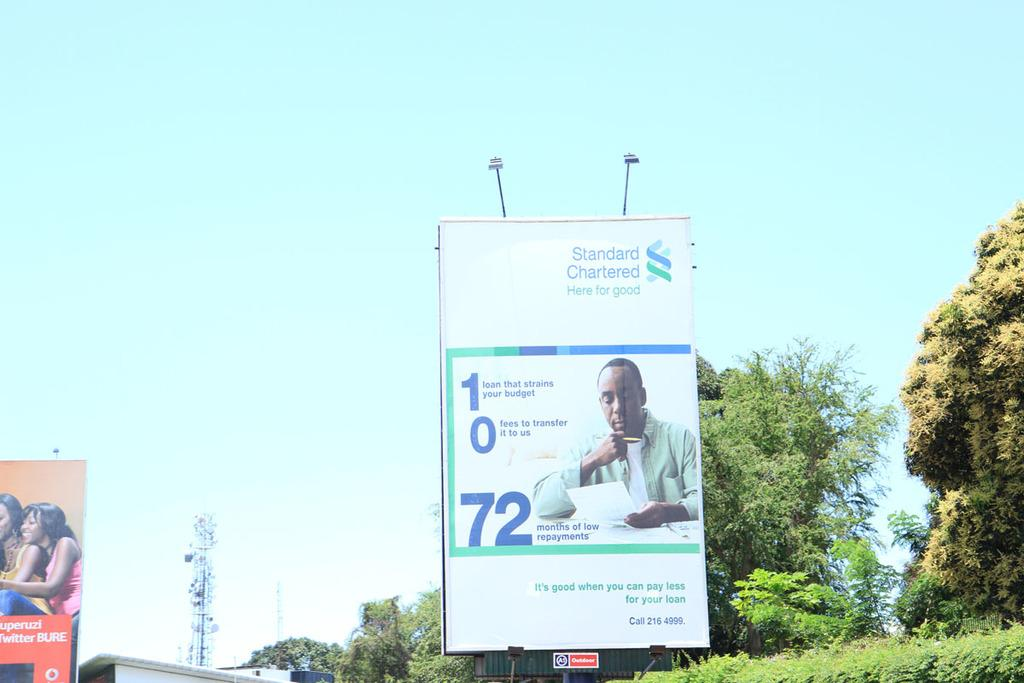<image>
Share a concise interpretation of the image provided. Large white sign hanging which says "Standard Chartered". 